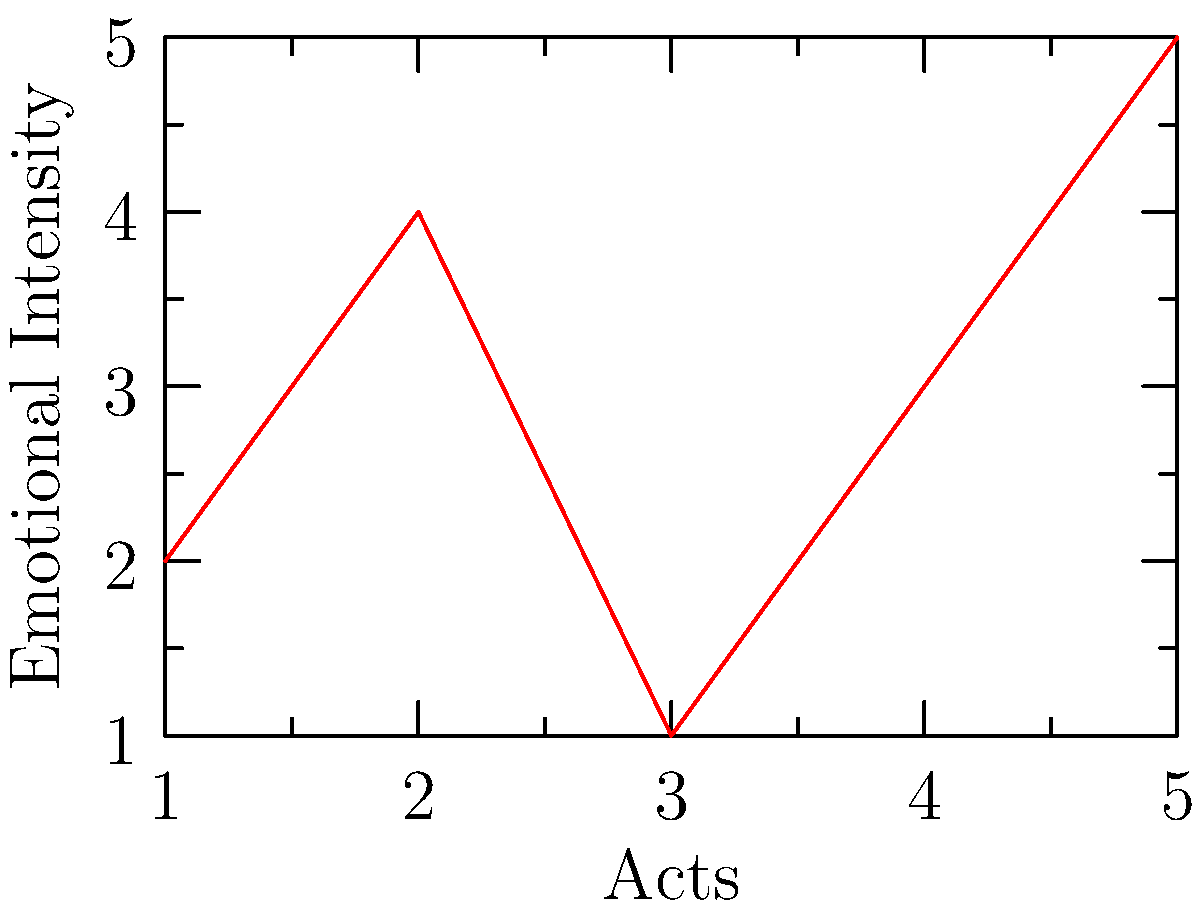Analyze the line graph representing the emotional journey of the protagonist throughout a five-act play. Which act marks the emotional nadir (lowest point) for the character, and how might this inform your interpretation of the play's dramatic structure? To answer this question, we need to follow these steps:

1. Examine the graph:
   The x-axis represents the Acts (1 to 5) of the play.
   The y-axis represents the Emotional Intensity of the protagonist.

2. Identify the lowest point:
   Act 1: Emotional Intensity ≈ 2
   Act 2: Emotional Intensity ≈ 4
   Act 3: Emotional Intensity ≈ 1
   Act 4: Emotional Intensity ≈ 3
   Act 5: Emotional Intensity ≈ 5

   The lowest point occurs in Act 3, with an Emotional Intensity of approximately 1.

3. Interpret the dramatic structure:
   - The emotional nadir in Act 3 aligns with classical dramatic structure, particularly Freytag's Pyramid.
   - Act 3 often contains the climax or turning point in a five-act structure.
   - The low emotional point suggests a moment of crisis, defeat, or revelation for the protagonist.
   - This structure creates tension and sets up the protagonist's recovery and resolution in Acts 4 and 5.

4. Consider the implications:
   - The steep decline from Act 2 to Act 3 indicates a significant dramatic event or revelation.
   - The upward trajectory in Acts 4 and 5 suggests a positive resolution or character growth.
   - This structure can be used to analyze the play's themes, character development, and overall message.
Answer: Act 3; it represents the climax or turning point, setting up the protagonist's recovery and the play's resolution. 